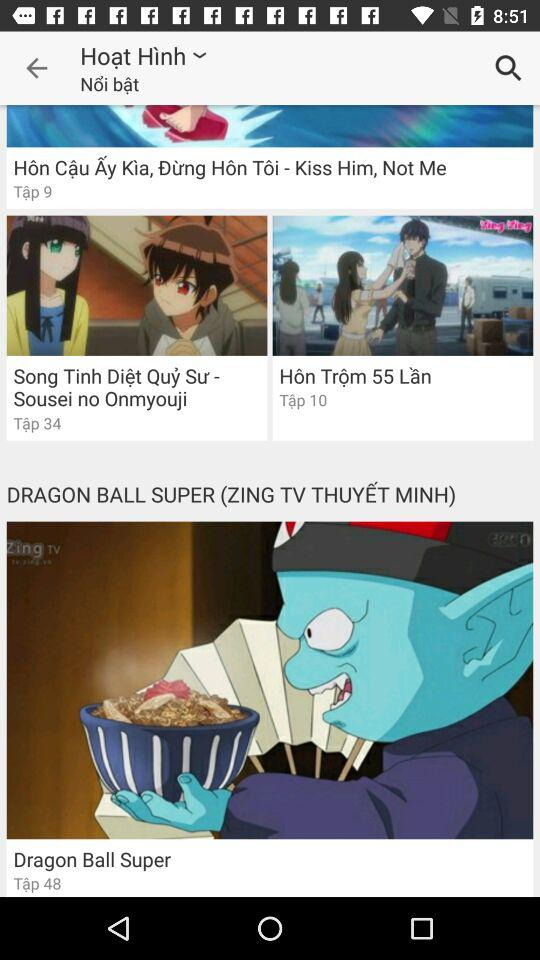How many episodes of Kiss Him, Not Me are there?
Answer the question using a single word or phrase. 9 